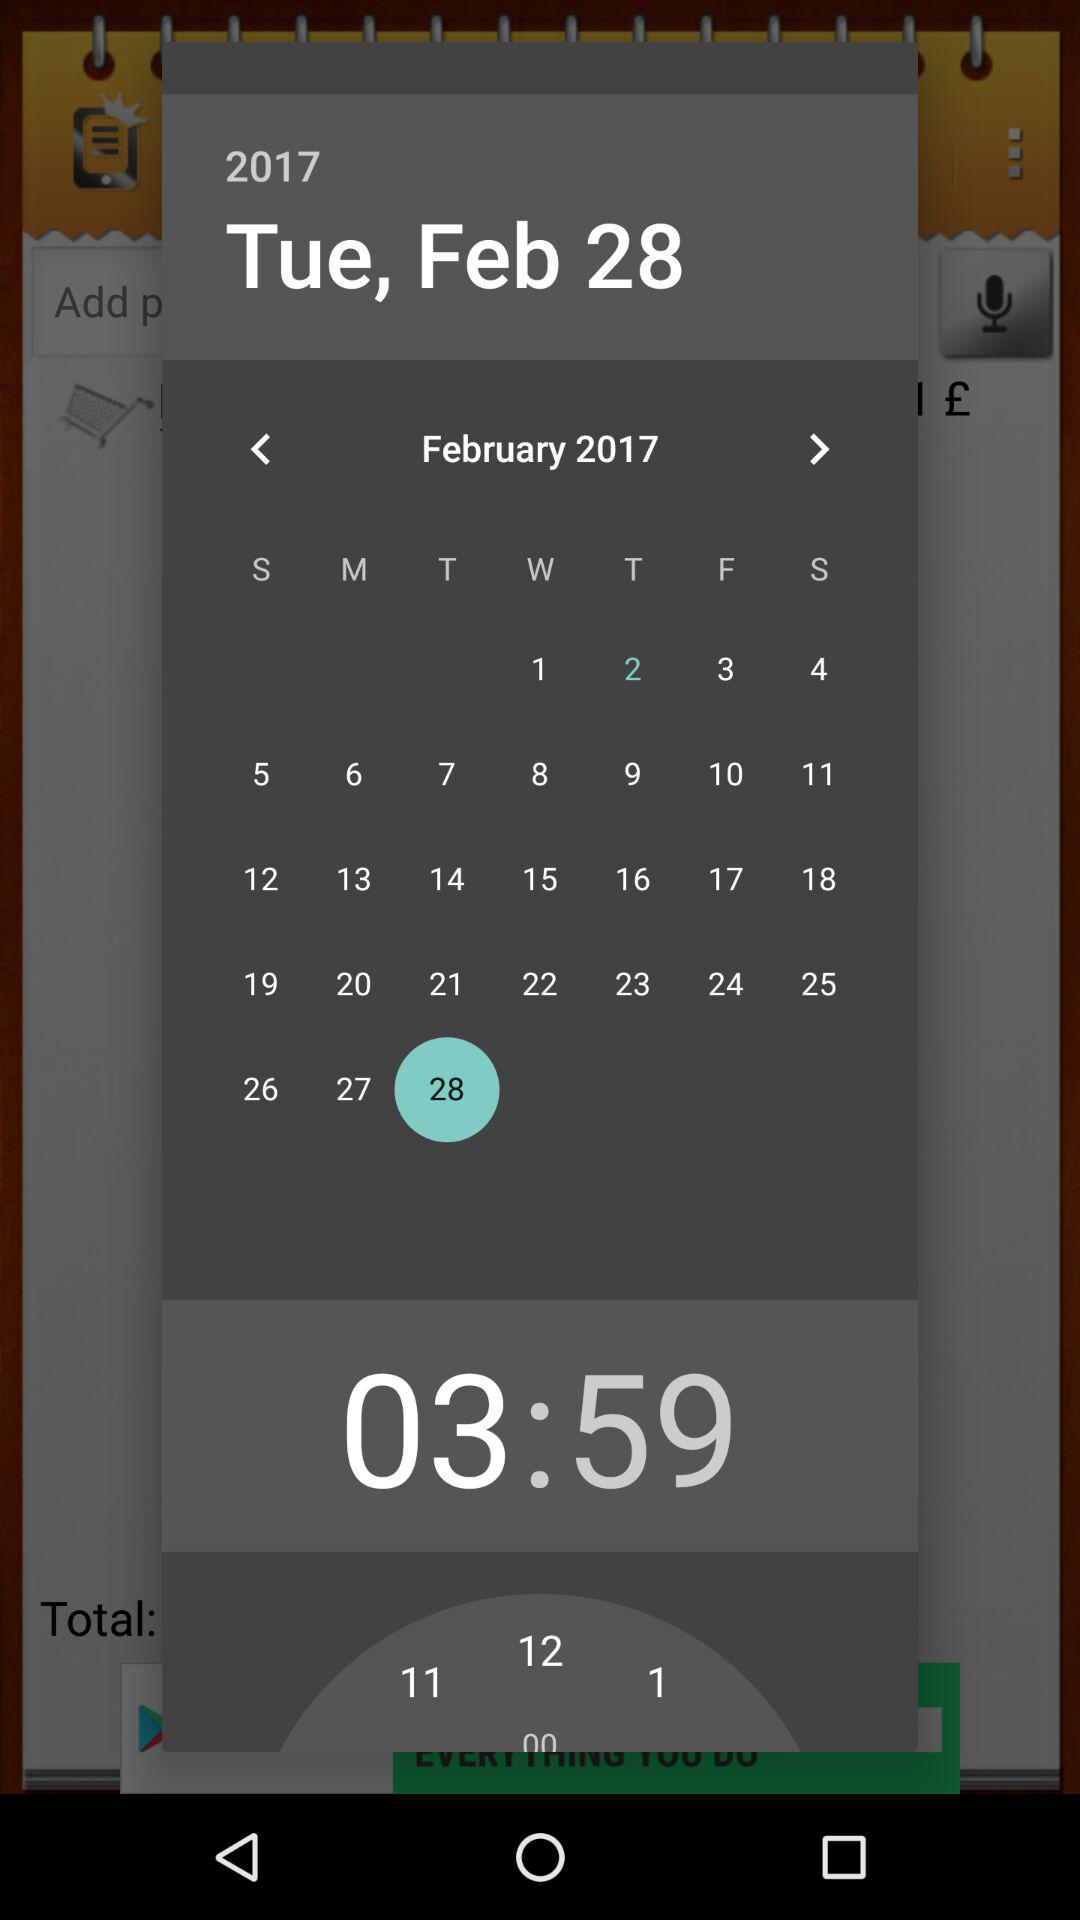Which day of the week does March 28, 2017, fall on?
When the provided information is insufficient, respond with <no answer>. <no answer> 